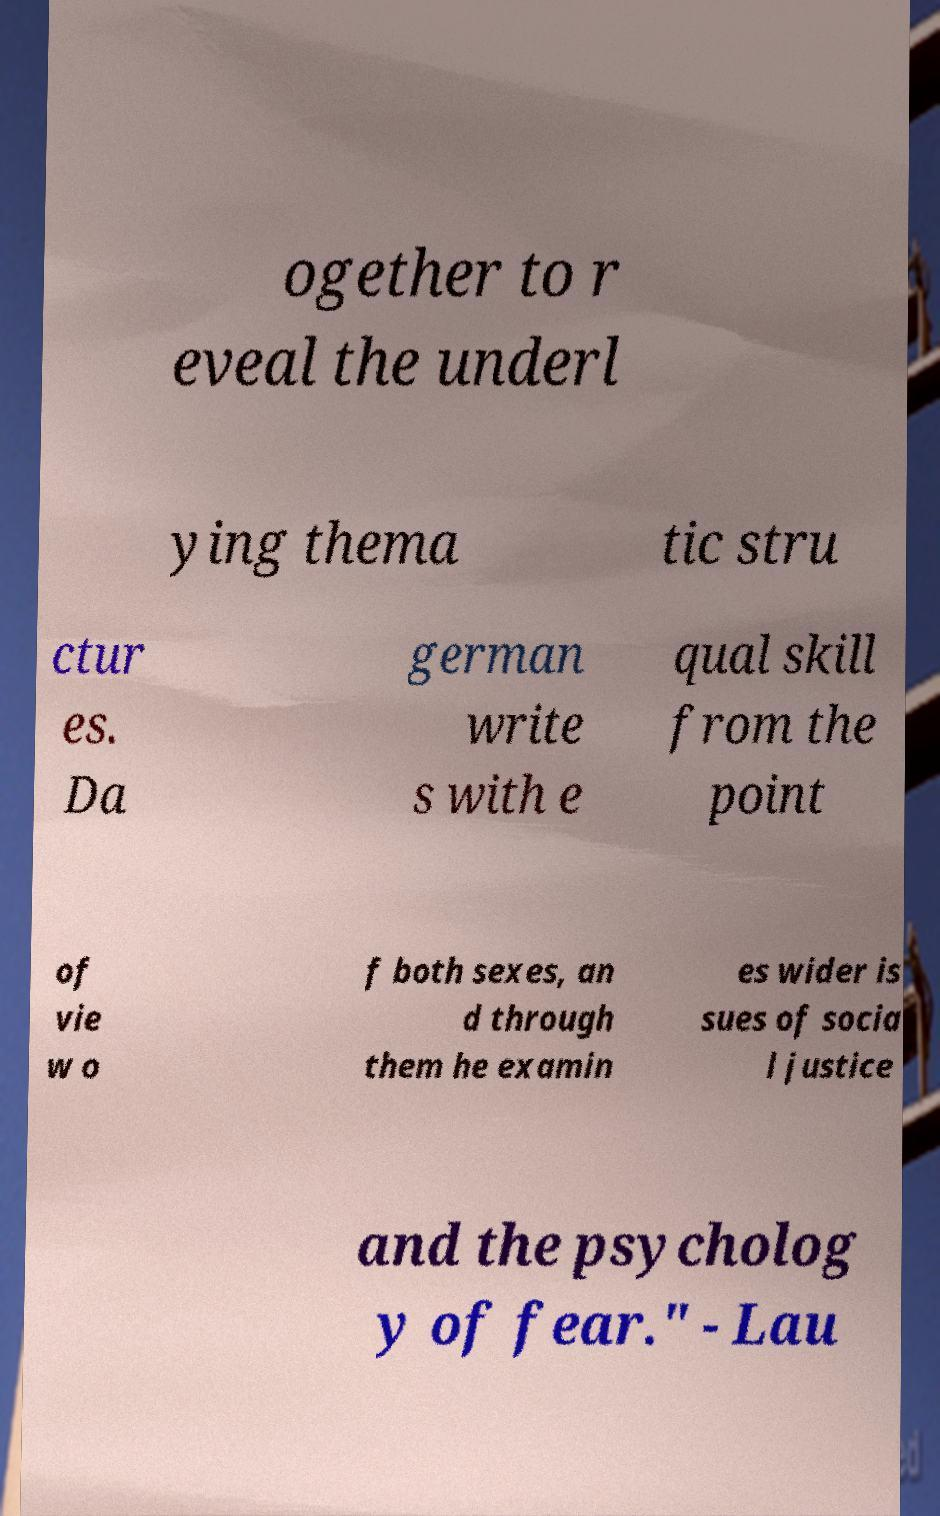There's text embedded in this image that I need extracted. Can you transcribe it verbatim? ogether to r eveal the underl ying thema tic stru ctur es. Da german write s with e qual skill from the point of vie w o f both sexes, an d through them he examin es wider is sues of socia l justice and the psycholog y of fear." - Lau 